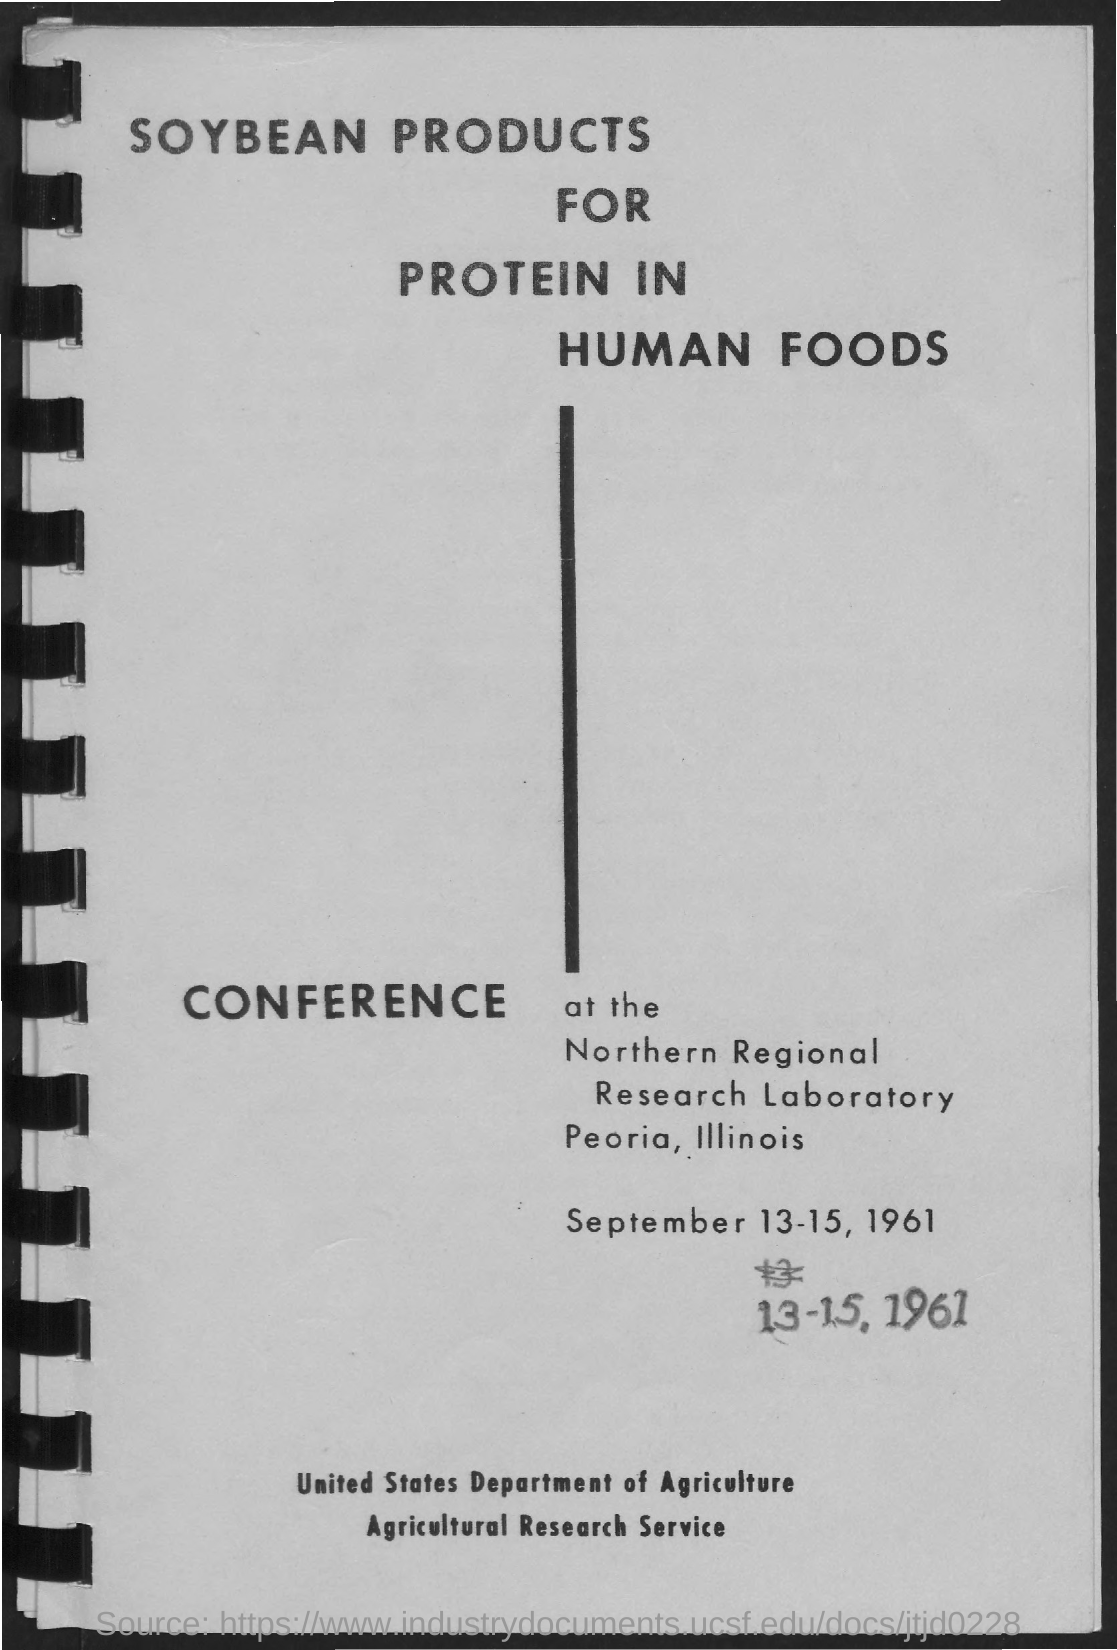Draw attention to some important aspects in this diagram. The city and state in which the event is held is Peoria, Illinois. The conference will take place from September 13-15, 1961. 